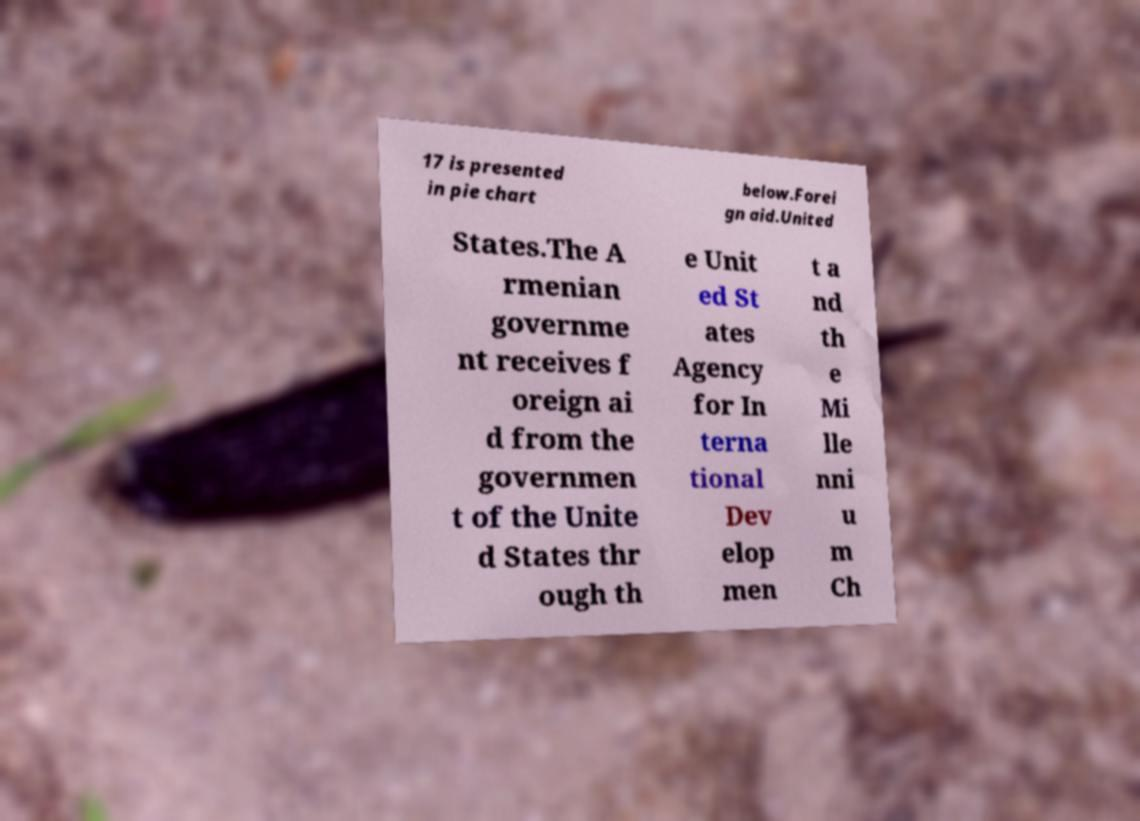For documentation purposes, I need the text within this image transcribed. Could you provide that? 17 is presented in pie chart below.Forei gn aid.United States.The A rmenian governme nt receives f oreign ai d from the governmen t of the Unite d States thr ough th e Unit ed St ates Agency for In terna tional Dev elop men t a nd th e Mi lle nni u m Ch 